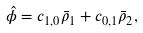Convert formula to latex. <formula><loc_0><loc_0><loc_500><loc_500>\hat { \phi } = c _ { 1 , 0 } \bar { \rho } _ { 1 } + c _ { 0 , 1 } \bar { \rho } _ { 2 } ,</formula> 